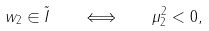<formula> <loc_0><loc_0><loc_500><loc_500>w _ { 2 } \in \tilde { I } \quad \Longleftrightarrow \quad \mu _ { 2 } ^ { 2 } < 0 ,</formula> 